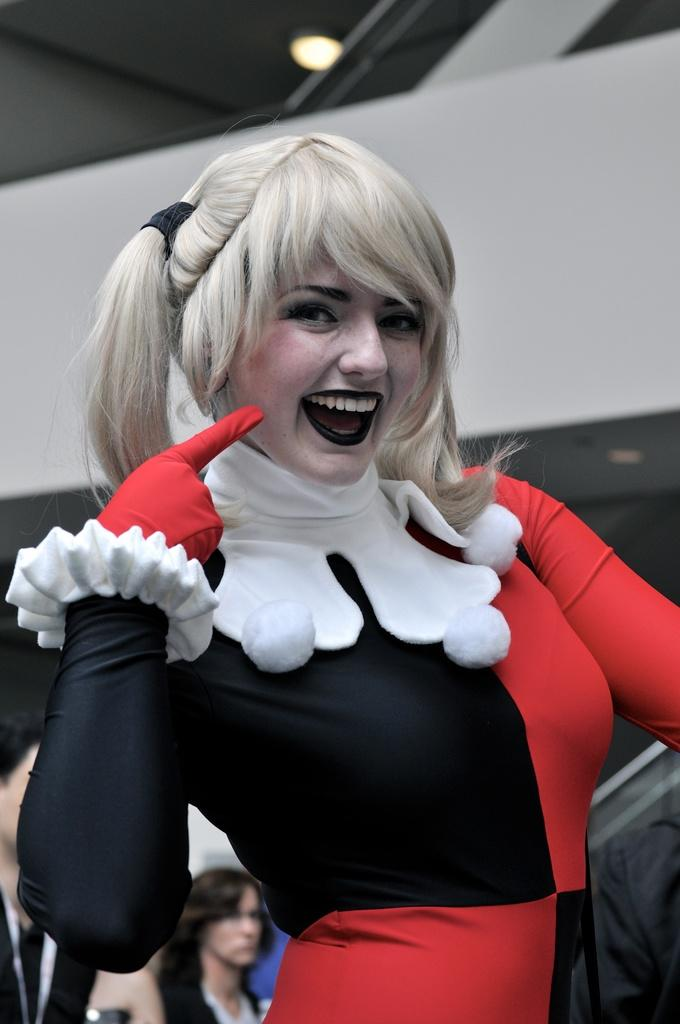What is the woman in the image wearing? The woman is wearing a costume in the image. Where are the people located in the image? The people are at the left bottom of the image. What can be seen in the background of the image? There is a wall in the background of the image. What is attached to the roof at the top of the image? There is a light attached to the roof at the top of the image. How many babies are crawling on the wall in the image? There are no babies present in the image, and they are not crawling on the wall. 